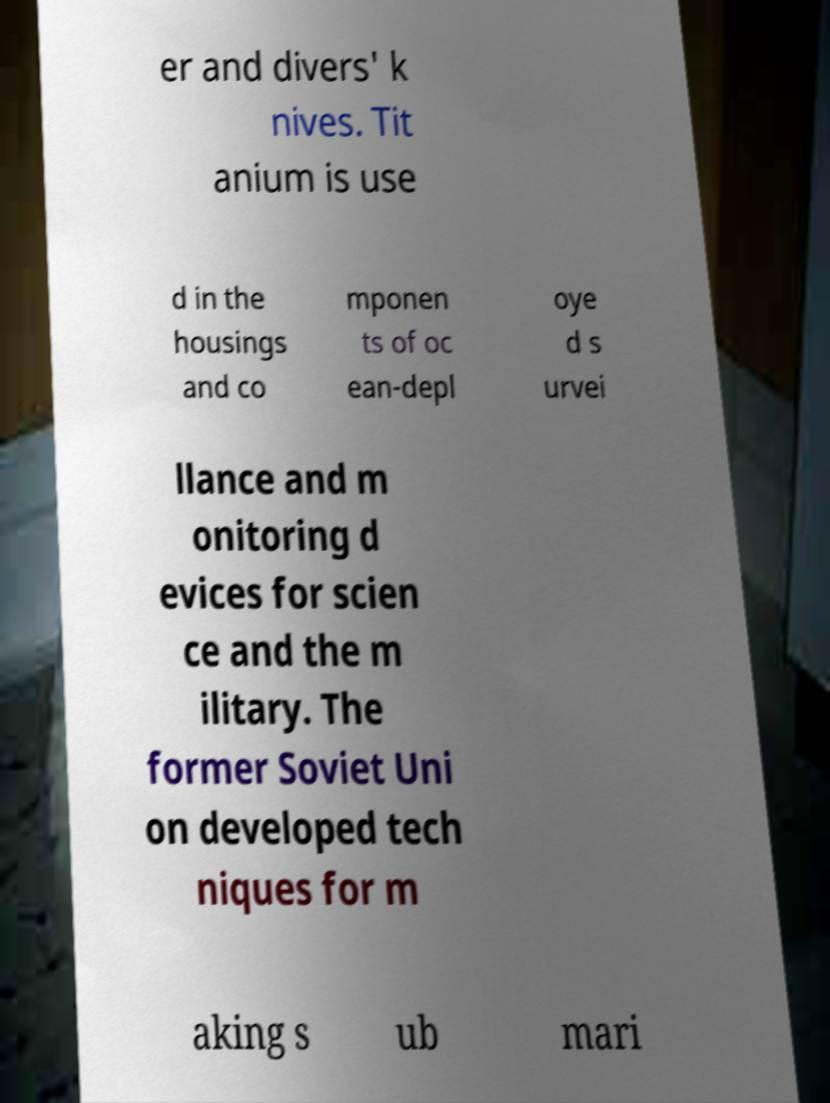I need the written content from this picture converted into text. Can you do that? er and divers' k nives. Tit anium is use d in the housings and co mponen ts of oc ean-depl oye d s urvei llance and m onitoring d evices for scien ce and the m ilitary. The former Soviet Uni on developed tech niques for m aking s ub mari 